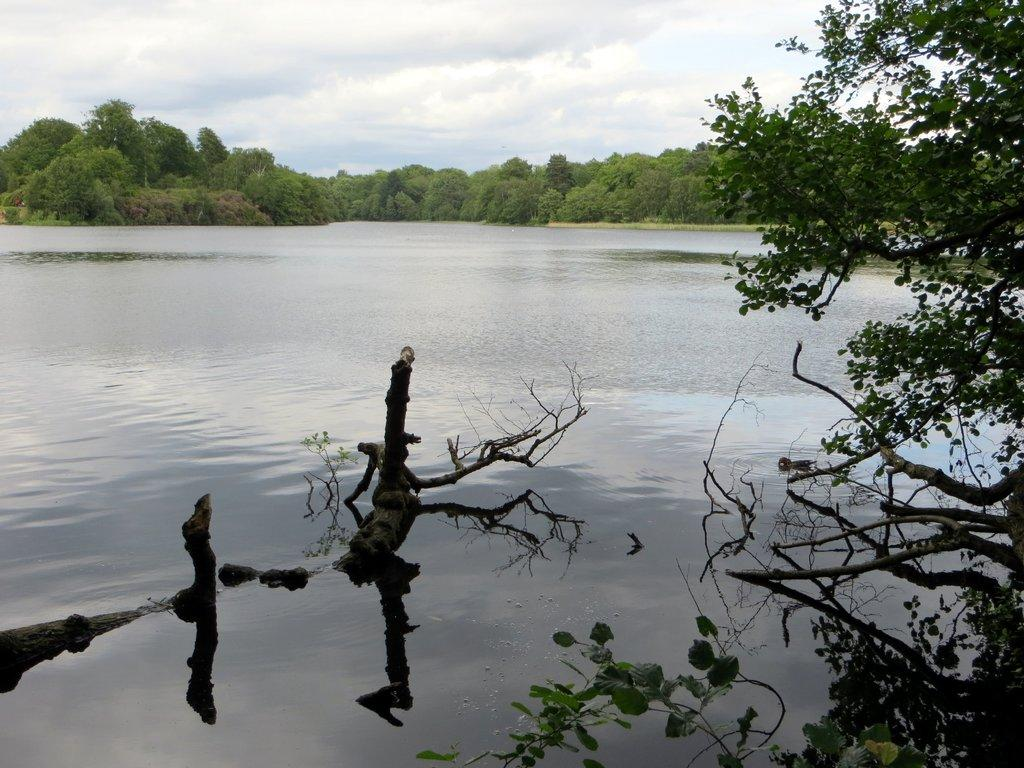What can be seen in the background of the image? The sky is visible in the image. What is present in the sky? There are clouds in the sky. What type of vegetation can be seen in the image? There are trees in the image. What body of water is present in the image? There is a lake in the image. How many sheep are grazing near the lake in the image? There are no sheep present in the image. What type of can is floating on the lake in the image? There is no can present in the image; it features a sky with clouds, trees, and a lake. 